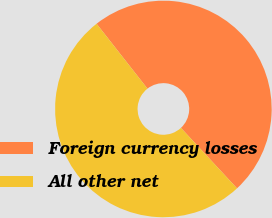Convert chart. <chart><loc_0><loc_0><loc_500><loc_500><pie_chart><fcel>Foreign currency losses<fcel>All other net<nl><fcel>48.68%<fcel>51.32%<nl></chart> 